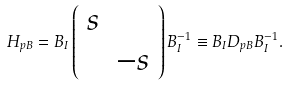Convert formula to latex. <formula><loc_0><loc_0><loc_500><loc_500>H _ { p B } = B _ { I } \left ( \begin{array} { c c } s & \\ & - s \end{array} \right ) B _ { I } ^ { - 1 } \equiv B _ { I } D _ { p B } B _ { I } ^ { - 1 } .</formula> 